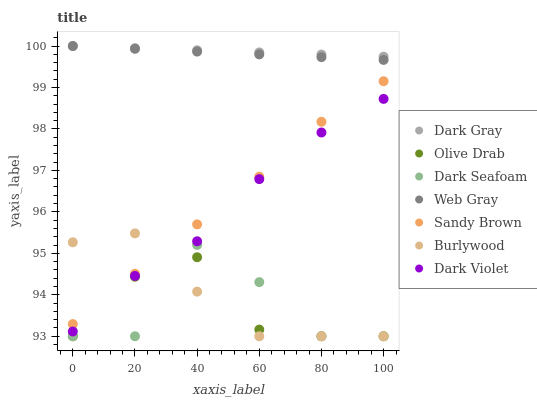Does Olive Drab have the minimum area under the curve?
Answer yes or no. Yes. Does Dark Gray have the maximum area under the curve?
Answer yes or no. Yes. Does Burlywood have the minimum area under the curve?
Answer yes or no. No. Does Burlywood have the maximum area under the curve?
Answer yes or no. No. Is Web Gray the smoothest?
Answer yes or no. Yes. Is Dark Seafoam the roughest?
Answer yes or no. Yes. Is Burlywood the smoothest?
Answer yes or no. No. Is Burlywood the roughest?
Answer yes or no. No. Does Burlywood have the lowest value?
Answer yes or no. Yes. Does Dark Violet have the lowest value?
Answer yes or no. No. Does Dark Gray have the highest value?
Answer yes or no. Yes. Does Burlywood have the highest value?
Answer yes or no. No. Is Olive Drab less than Dark Violet?
Answer yes or no. Yes. Is Web Gray greater than Sandy Brown?
Answer yes or no. Yes. Does Burlywood intersect Sandy Brown?
Answer yes or no. Yes. Is Burlywood less than Sandy Brown?
Answer yes or no. No. Is Burlywood greater than Sandy Brown?
Answer yes or no. No. Does Olive Drab intersect Dark Violet?
Answer yes or no. No. 